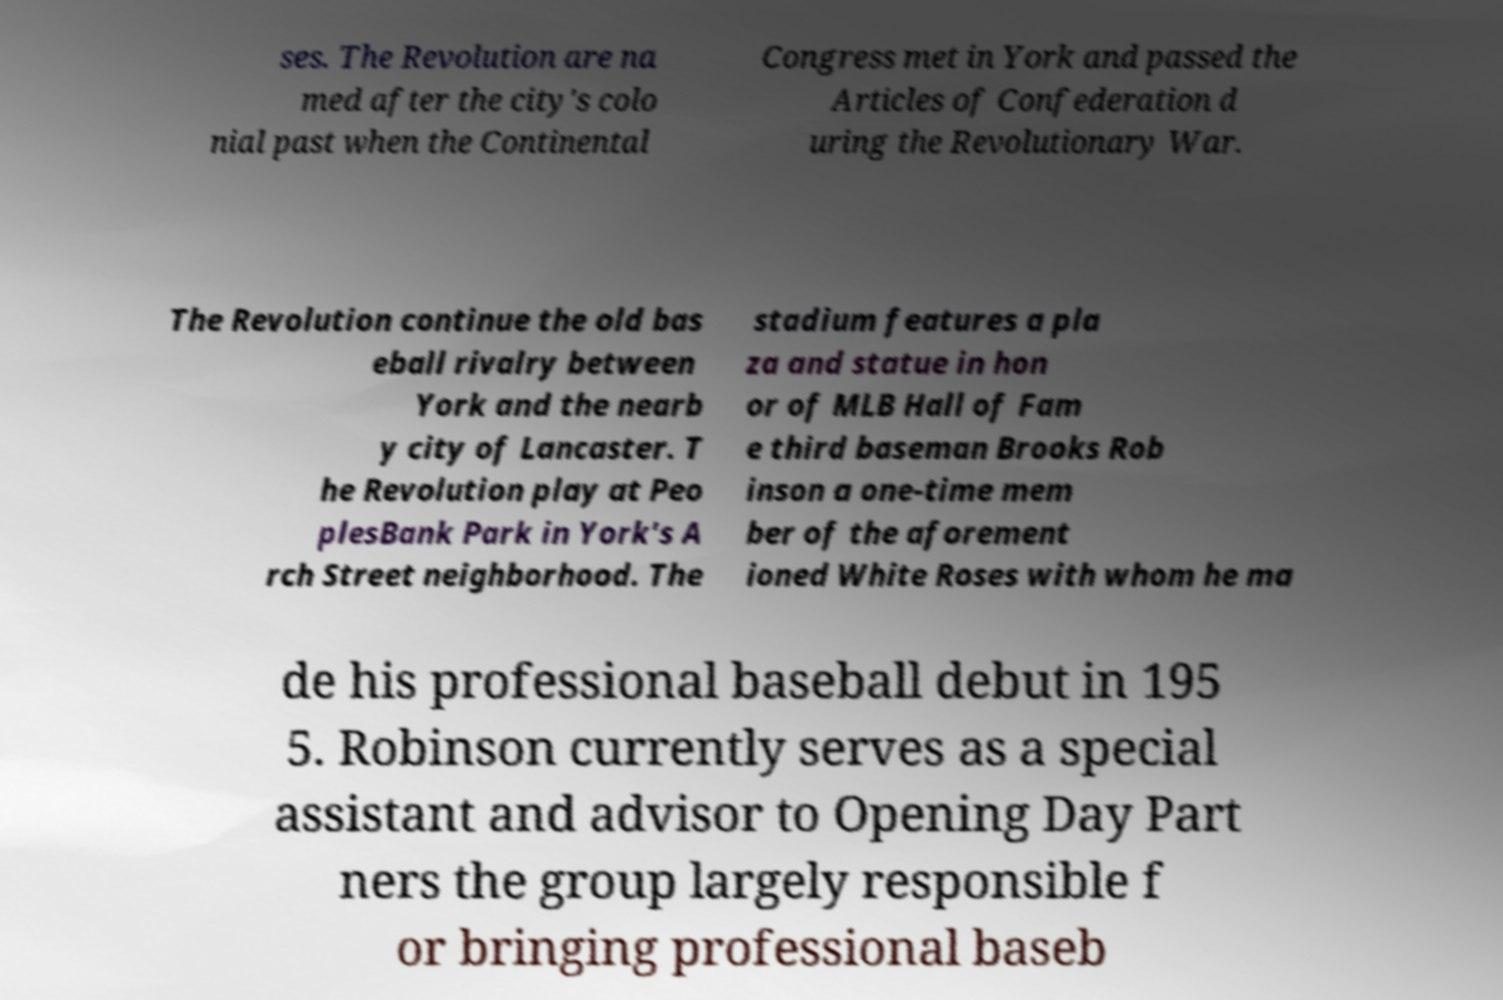Can you accurately transcribe the text from the provided image for me? ses. The Revolution are na med after the city's colo nial past when the Continental Congress met in York and passed the Articles of Confederation d uring the Revolutionary War. The Revolution continue the old bas eball rivalry between York and the nearb y city of Lancaster. T he Revolution play at Peo plesBank Park in York's A rch Street neighborhood. The stadium features a pla za and statue in hon or of MLB Hall of Fam e third baseman Brooks Rob inson a one-time mem ber of the aforement ioned White Roses with whom he ma de his professional baseball debut in 195 5. Robinson currently serves as a special assistant and advisor to Opening Day Part ners the group largely responsible f or bringing professional baseb 